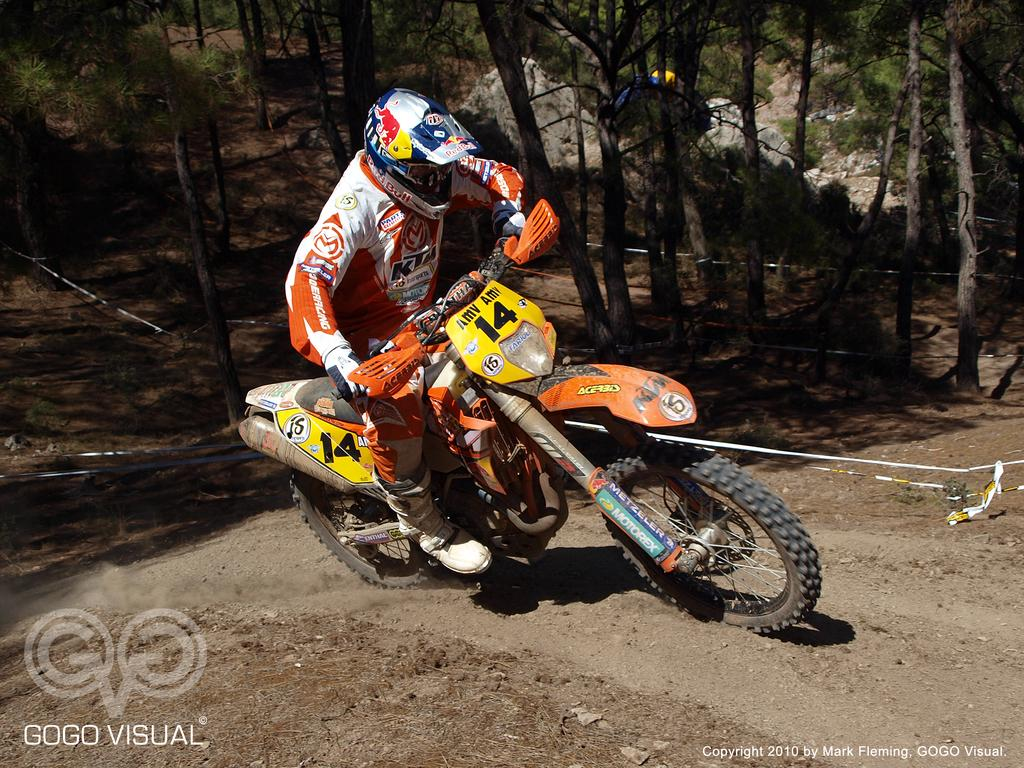What is the person in the image doing? The person in the image is riding a bike. What can be seen on the person while they are riding the bike? The person is wearing a white and orange color dress. What is visible in the background of the image? There are trees in the background of the image. What is the color of the trees in the image? The trees are green in color. How many pets are visible in the image? There are no pets visible in the image. Are the person's brothers also riding bikes in the image? There is no information about the person's brothers in the image. Can you see a snail crawling on the bike in the image? There is no snail visible in the image. 